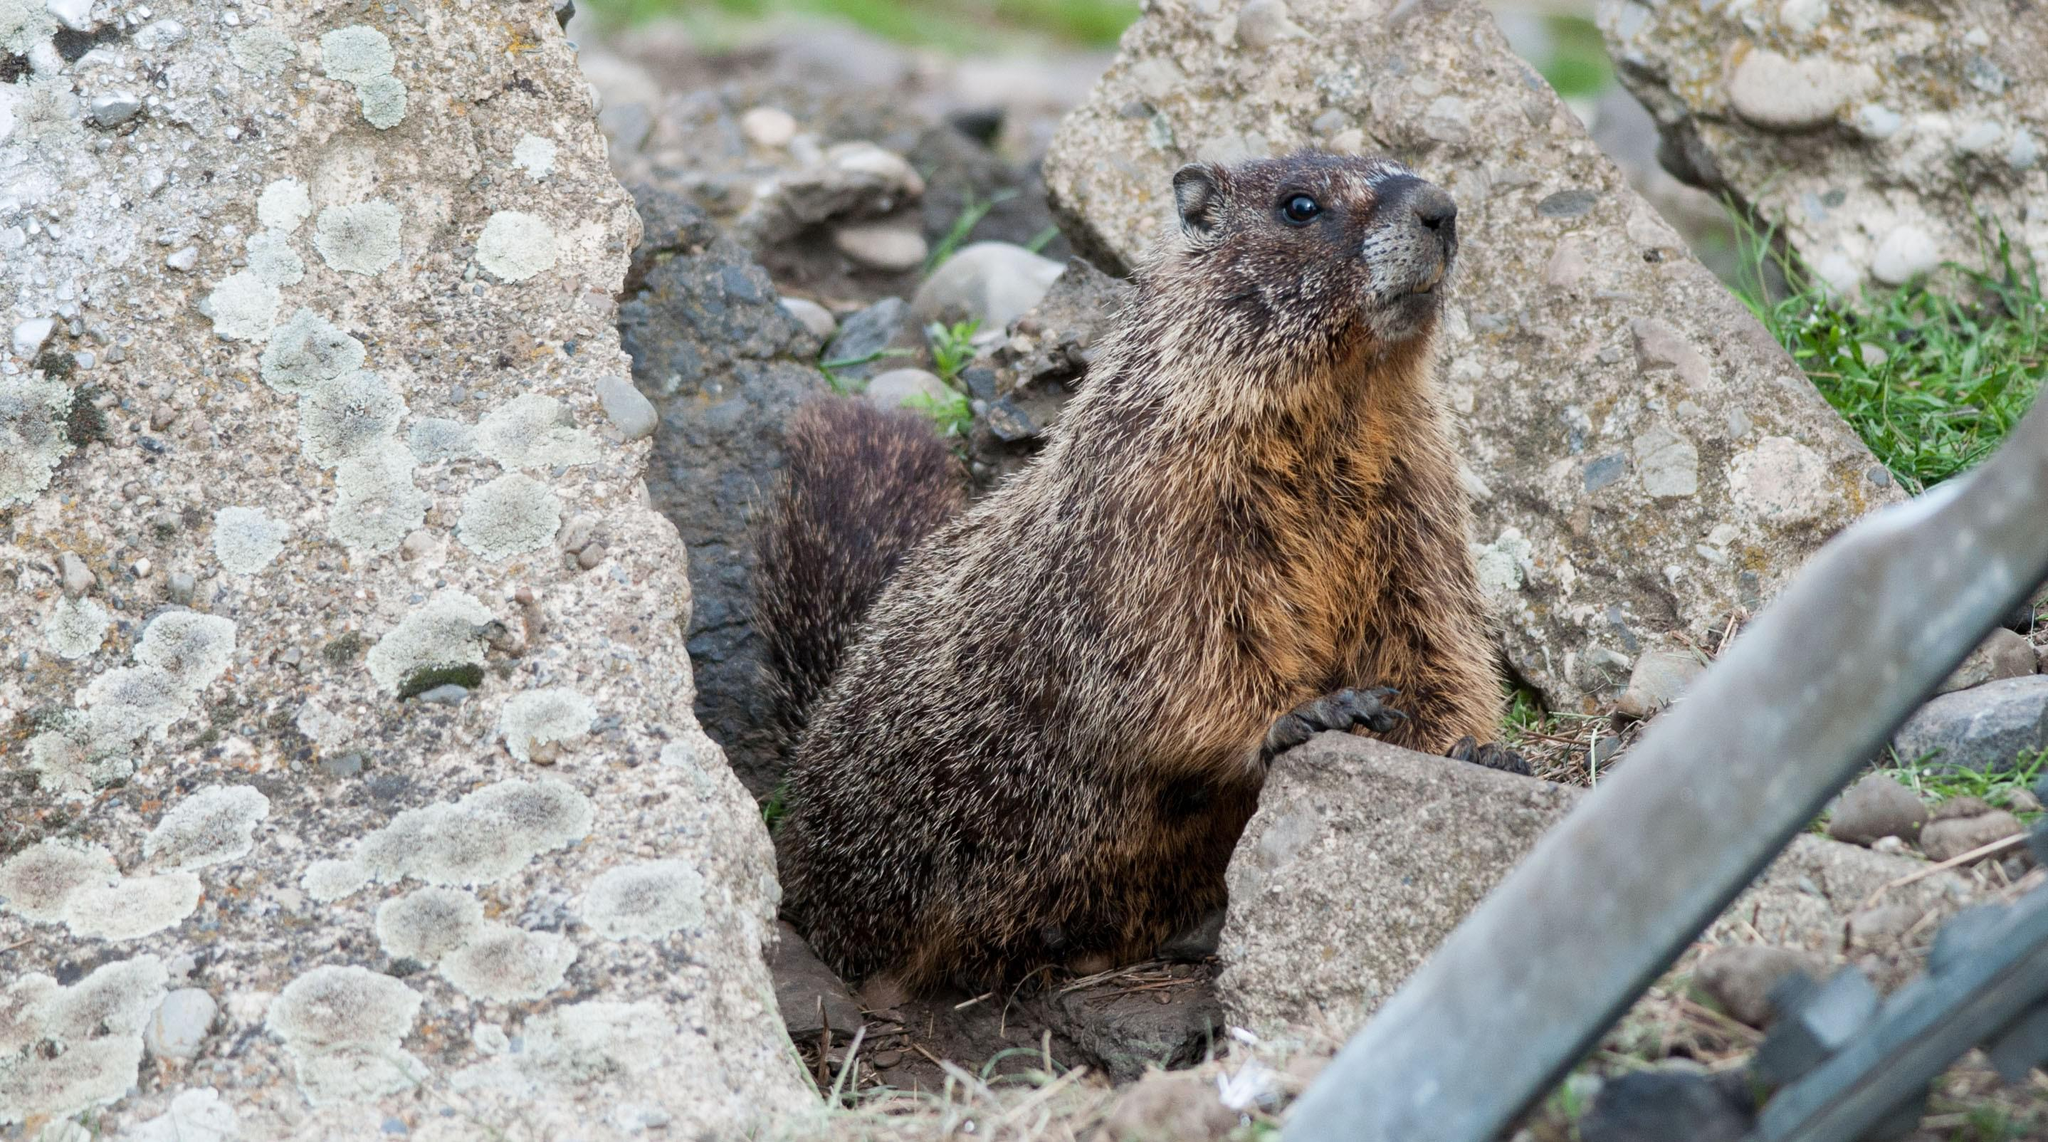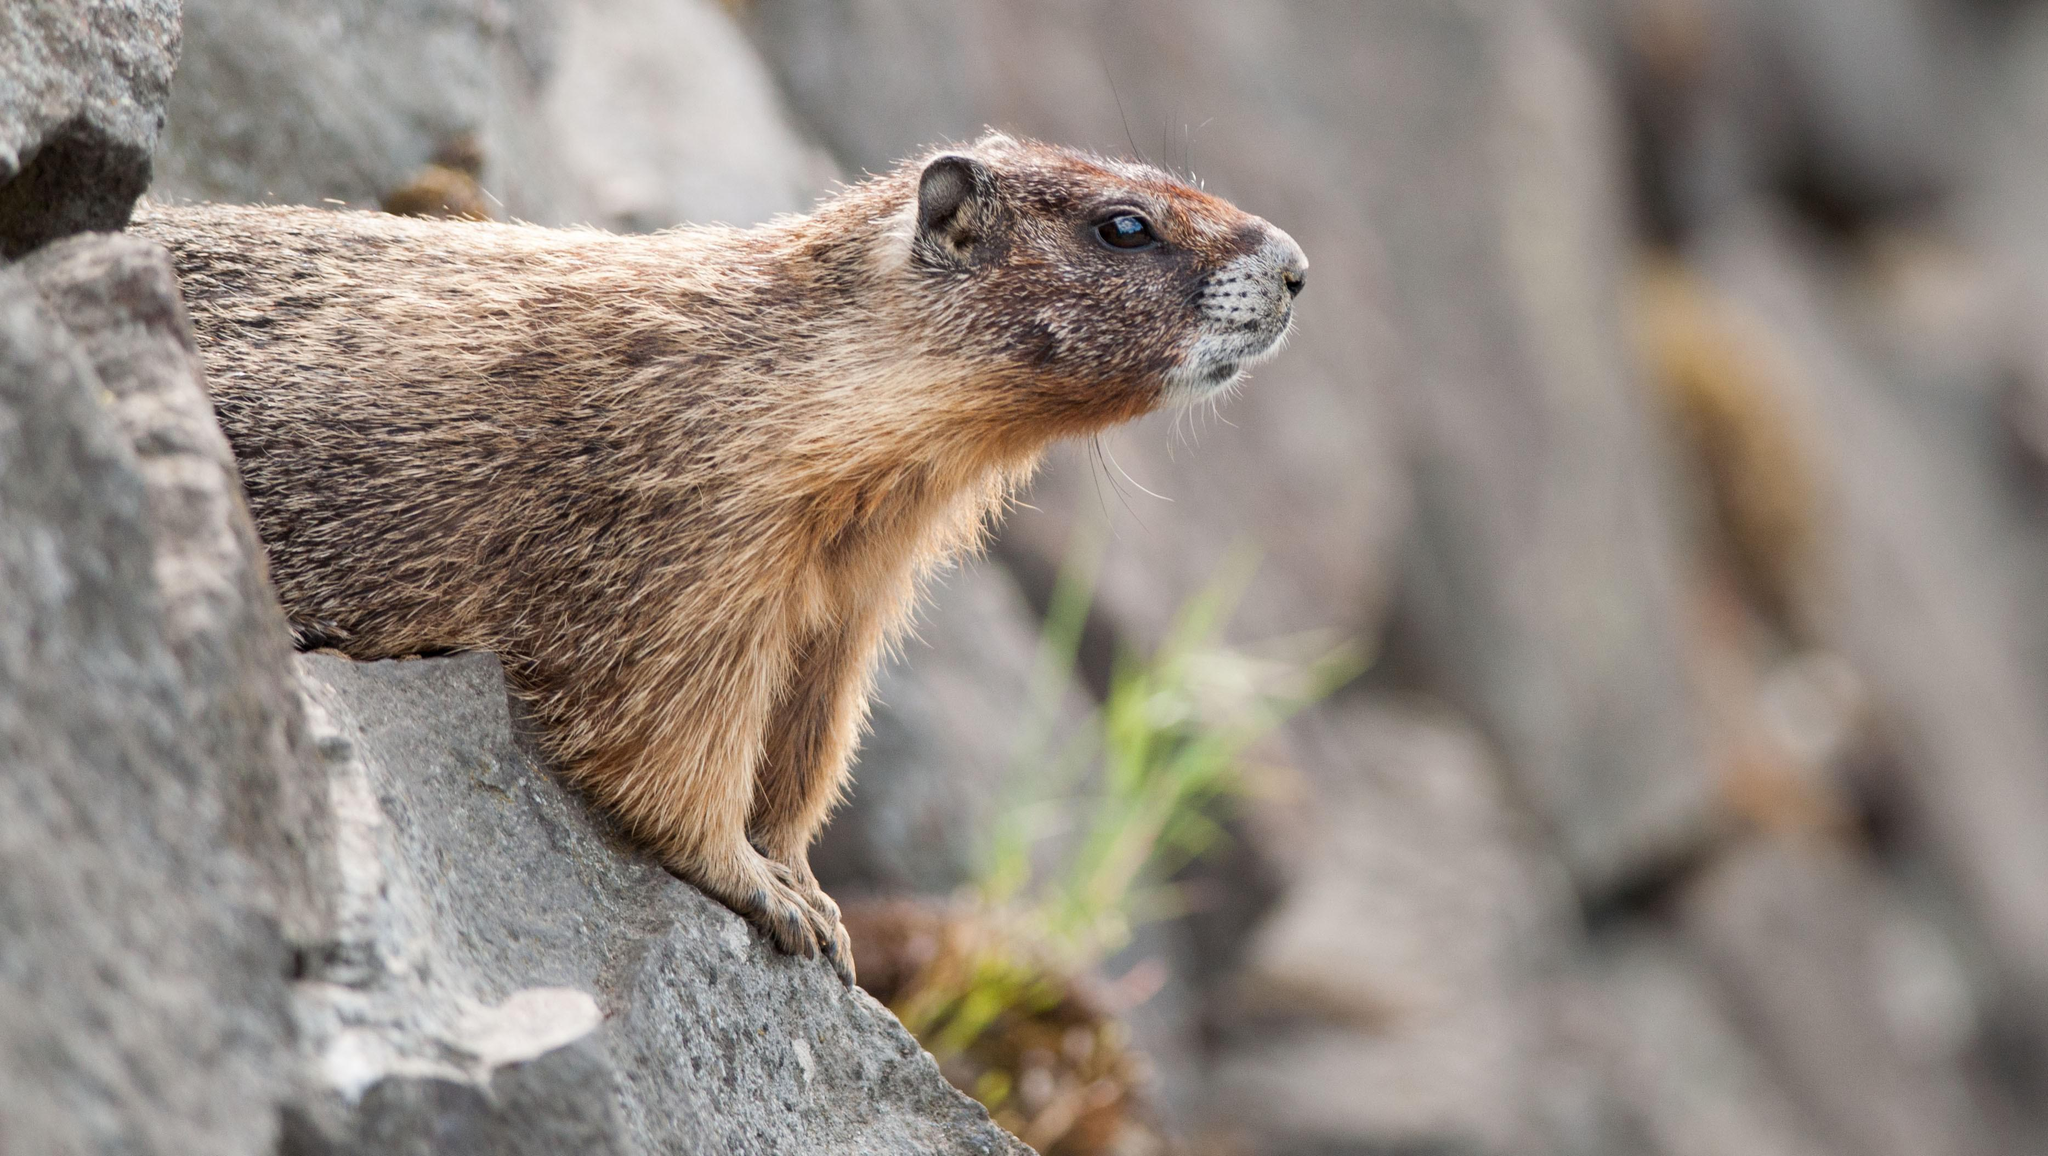The first image is the image on the left, the second image is the image on the right. Given the left and right images, does the statement "At least one of the small mammals is looking directly to the right, alone in it's own image." hold true? Answer yes or no. Yes. The first image is the image on the left, the second image is the image on the right. Examine the images to the left and right. Is the description "The left and right image contains a total of two groundhogs facing the same direction." accurate? Answer yes or no. Yes. 